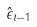Convert formula to latex. <formula><loc_0><loc_0><loc_500><loc_500>\hat { \epsilon } _ { t - 1 }</formula> 